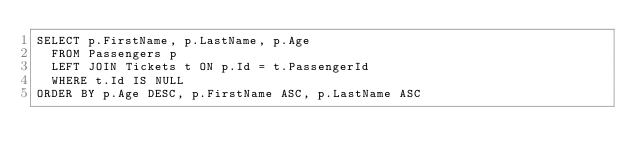Convert code to text. <code><loc_0><loc_0><loc_500><loc_500><_SQL_>SELECT p.FirstName, p.LastName, p.Age
  FROM Passengers p
  LEFT JOIN Tickets t ON p.Id = t.PassengerId
  WHERE t.Id IS NULL
ORDER BY p.Age DESC, p.FirstName ASC, p.LastName ASC</code> 